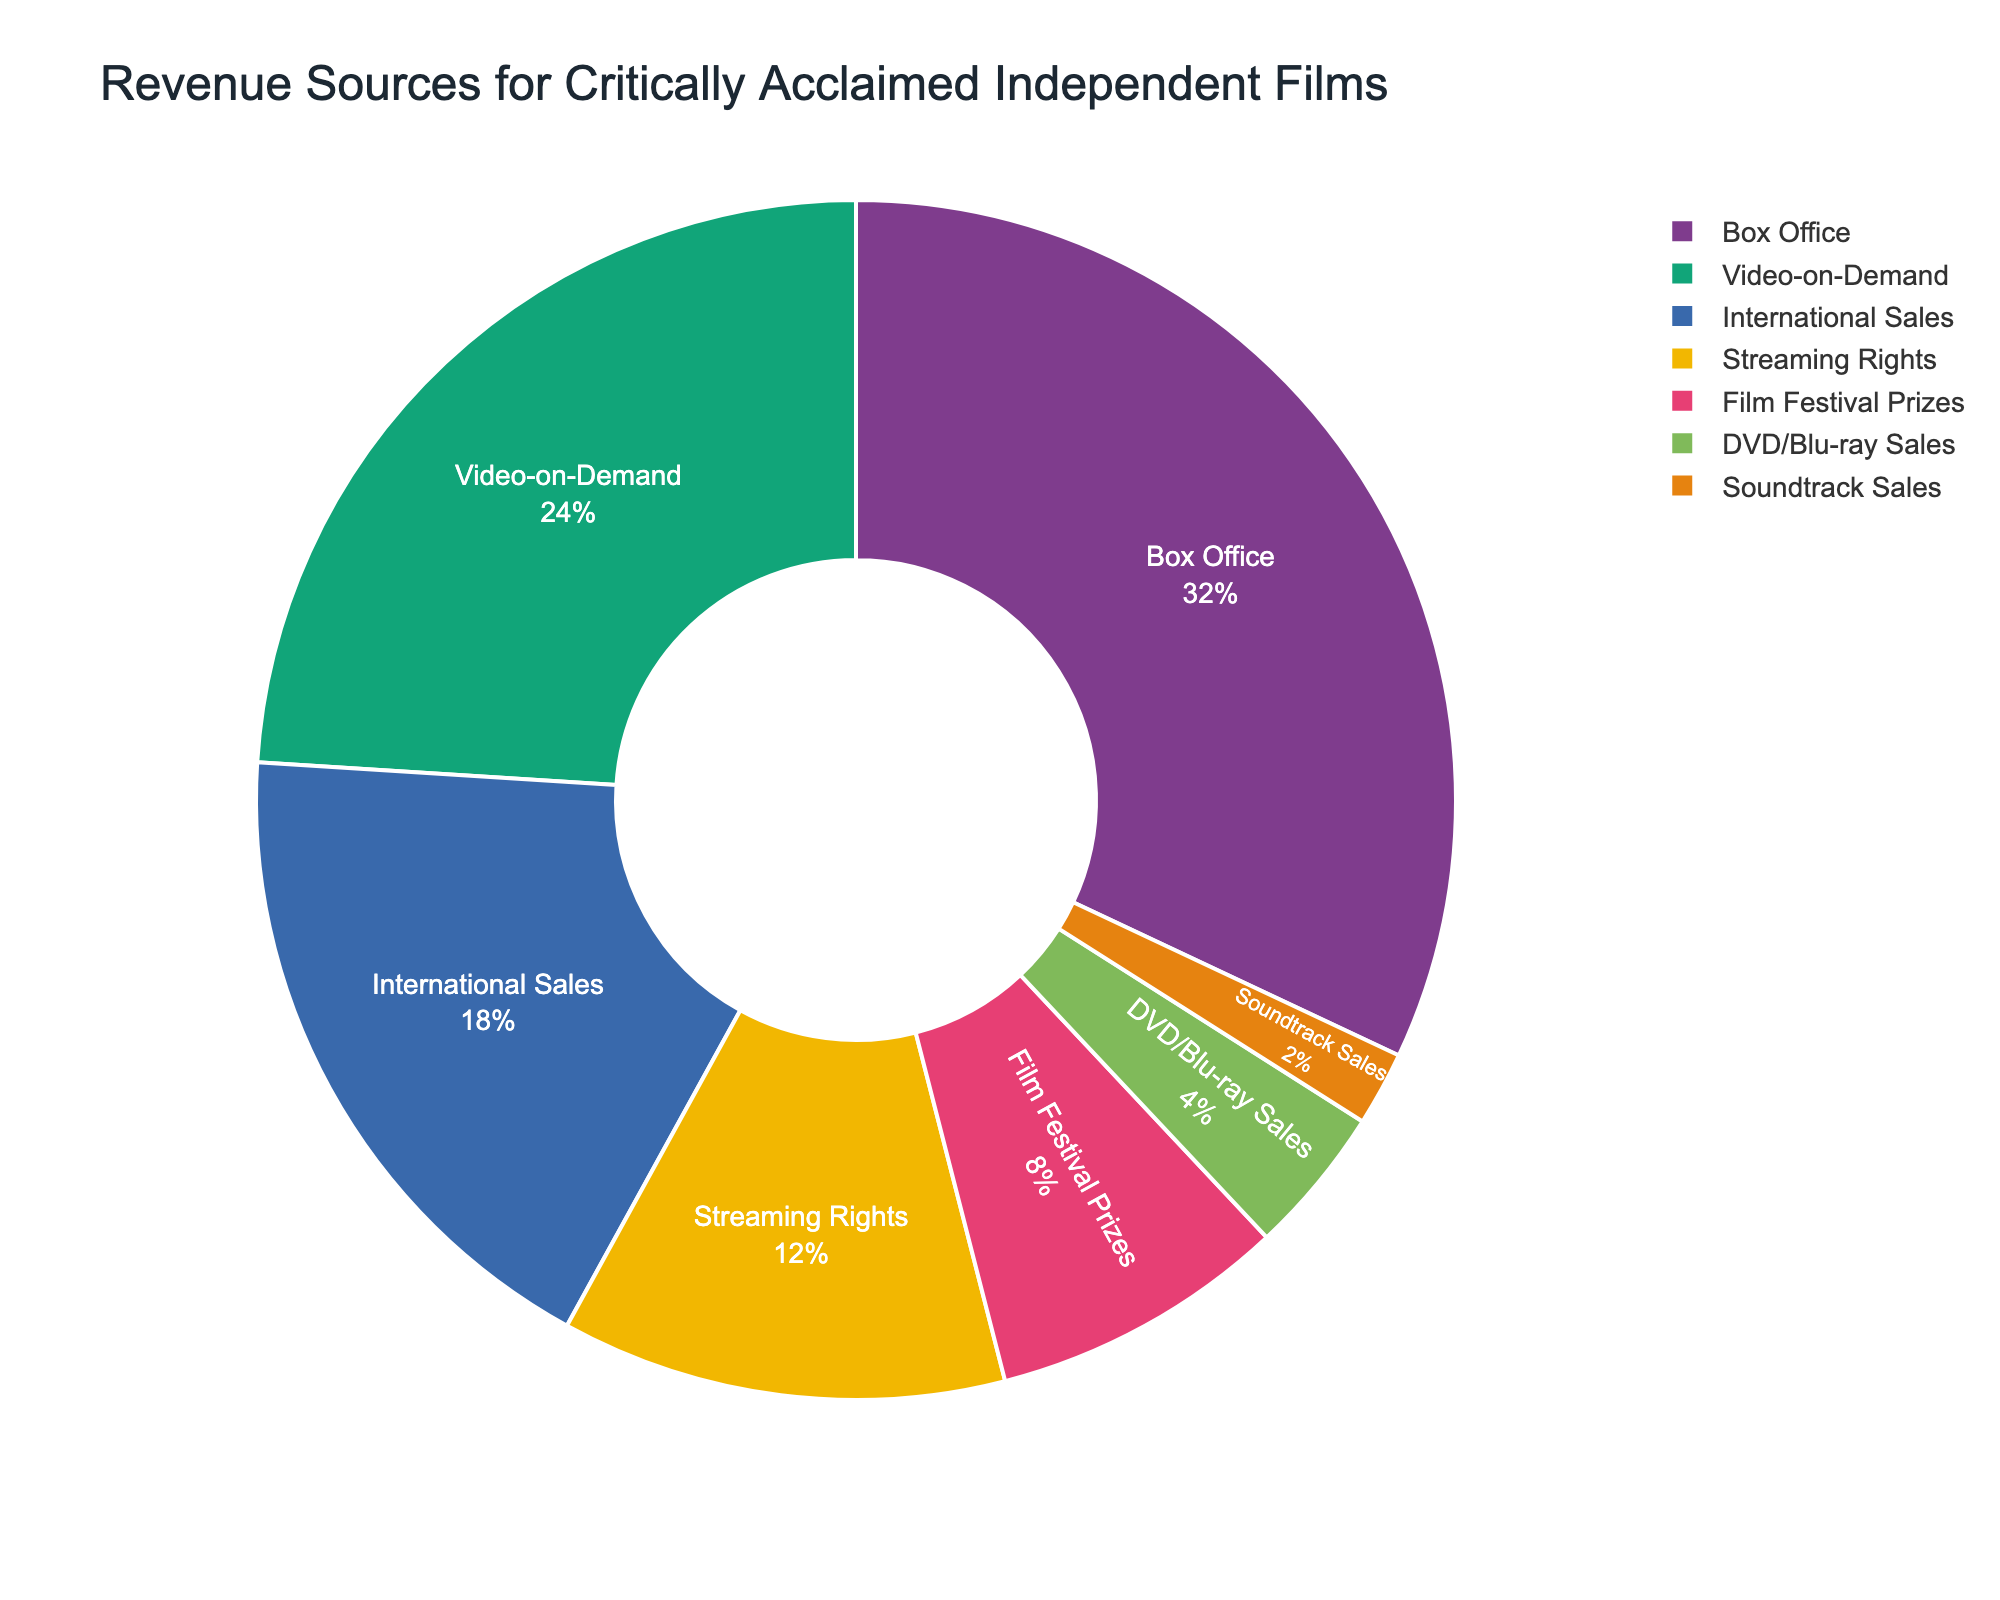What is the largest revenue source for critically acclaimed independent films? The pie chart shows the largest portion attributed to Box Office with 32%.
Answer: Box Office Which revenue source contributes less to the total revenue: International Sales or Streaming Rights? International Sales is represented by 18% while Streaming Rights is represented by 12%. Since 12% is less than 18%, Streaming Rights contributes less.
Answer: Streaming Rights What is the combined percentage of revenue from Film Festival Prizes and DVD/Blu-ray Sales? Film Festival Prizes are 8% and DVD/Blu-ray Sales are 4%. Adding these together, 8% + 4% = 12%.
Answer: 12% Which revenue source has the smallest contribution? The smallest segment in the pie chart corresponds to Soundtrack Sales with 2%.
Answer: Soundtrack Sales What is the difference in percentage between Video-on-Demand and International Sales revenue? Video-on-Demand is 24% and International Sales is 18%. Subtracting these, 24% - 18% = 6%.
Answer: 6% How much more does Box Office contribute compared to Film Festival Prizes? Box Office contributes 32% and Film Festival Prizes contribute 8%. The difference is 32% - 8% = 24%.
Answer: 24% If we combine revenue from Streaming Rights and Video-on-Demand, what percentage do they represent together? Streaming Rights make up 12% and Video-on-Demand makes 24%. Combined, they represent 12% + 24% = 36%.
Answer: 36% Which revenue source contributes more between DVD/Blu-ray Sales and Soundtrack Sales? DVD/Blu-ray Sales contribute 4%, while Soundtrack Sales contribute 2%. Since 4% is more than 2%, DVD/Blu-ray Sales contribute more.
Answer: DVD/Blu-ray Sales What is the visual attribute that differentiates the revenue sources on the chart? Each revenue source is differentiated by a unique color in the pie chart.
Answer: Color 